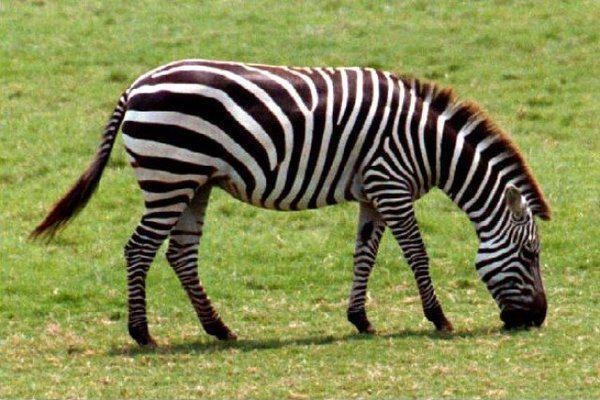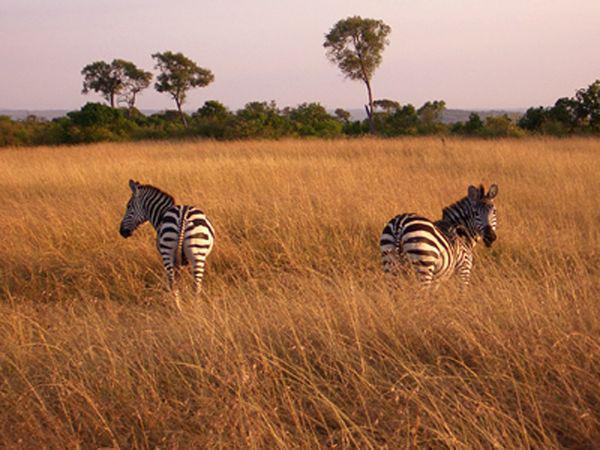The first image is the image on the left, the second image is the image on the right. Given the left and right images, does the statement "There are three zebras" hold true? Answer yes or no. Yes. 